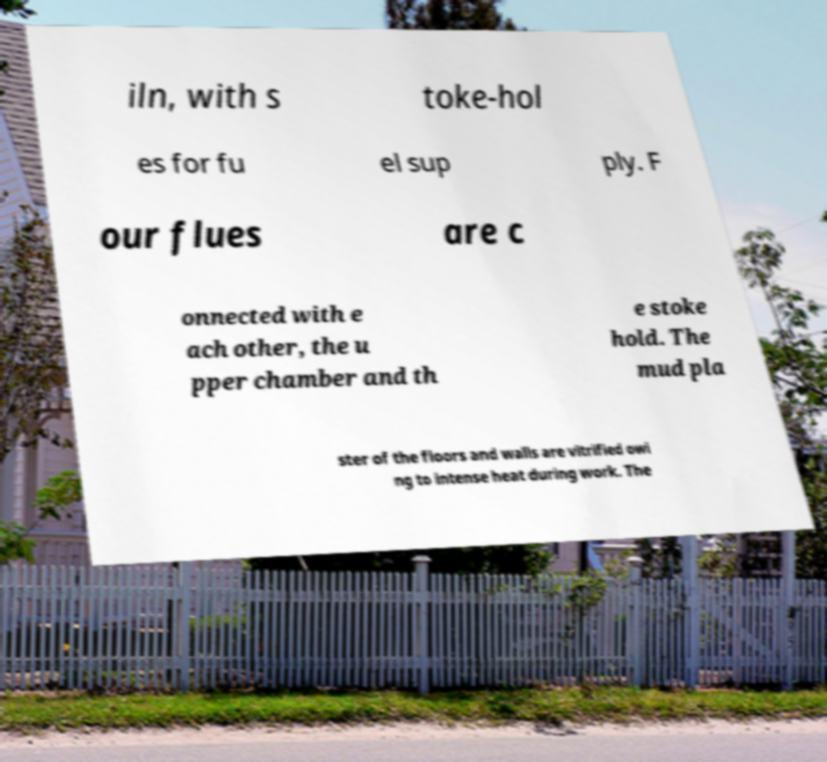Can you read and provide the text displayed in the image?This photo seems to have some interesting text. Can you extract and type it out for me? iln, with s toke-hol es for fu el sup ply. F our flues are c onnected with e ach other, the u pper chamber and th e stoke hold. The mud pla ster of the floors and walls are vitrified owi ng to intense heat during work. The 